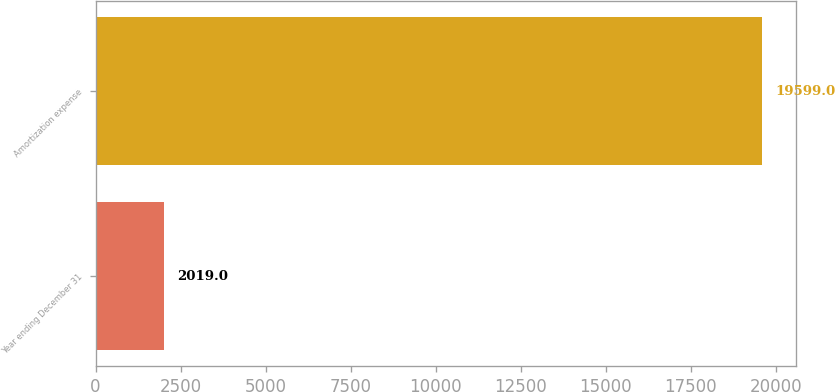<chart> <loc_0><loc_0><loc_500><loc_500><bar_chart><fcel>Year ending December 31<fcel>Amortization expense<nl><fcel>2019<fcel>19599<nl></chart> 